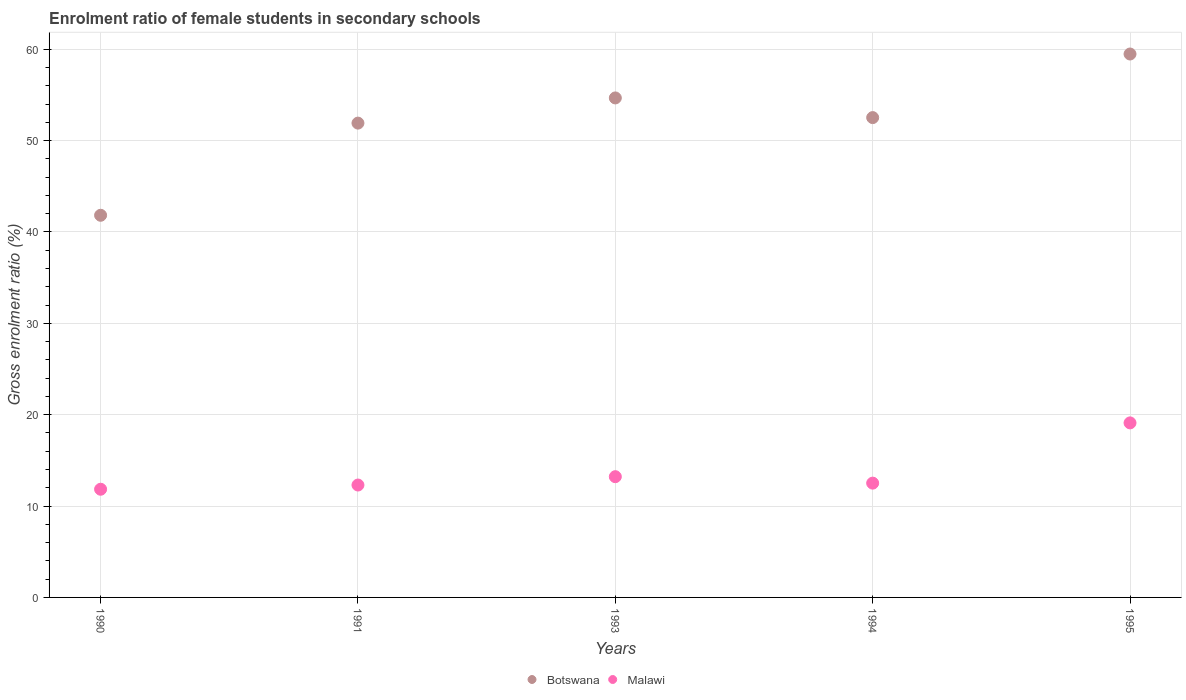Is the number of dotlines equal to the number of legend labels?
Offer a very short reply. Yes. What is the enrolment ratio of female students in secondary schools in Malawi in 1991?
Offer a very short reply. 12.3. Across all years, what is the maximum enrolment ratio of female students in secondary schools in Malawi?
Ensure brevity in your answer.  19.1. Across all years, what is the minimum enrolment ratio of female students in secondary schools in Botswana?
Give a very brief answer. 41.82. What is the total enrolment ratio of female students in secondary schools in Malawi in the graph?
Make the answer very short. 68.97. What is the difference between the enrolment ratio of female students in secondary schools in Malawi in 1990 and that in 1995?
Give a very brief answer. -7.26. What is the difference between the enrolment ratio of female students in secondary schools in Malawi in 1993 and the enrolment ratio of female students in secondary schools in Botswana in 1995?
Ensure brevity in your answer.  -46.26. What is the average enrolment ratio of female students in secondary schools in Botswana per year?
Your answer should be very brief. 52.08. In the year 1994, what is the difference between the enrolment ratio of female students in secondary schools in Botswana and enrolment ratio of female students in secondary schools in Malawi?
Provide a short and direct response. 40. In how many years, is the enrolment ratio of female students in secondary schools in Botswana greater than 48 %?
Offer a very short reply. 4. What is the ratio of the enrolment ratio of female students in secondary schools in Malawi in 1991 to that in 1995?
Your response must be concise. 0.64. Is the difference between the enrolment ratio of female students in secondary schools in Botswana in 1990 and 1993 greater than the difference between the enrolment ratio of female students in secondary schools in Malawi in 1990 and 1993?
Offer a terse response. No. What is the difference between the highest and the second highest enrolment ratio of female students in secondary schools in Botswana?
Give a very brief answer. 4.81. What is the difference between the highest and the lowest enrolment ratio of female students in secondary schools in Botswana?
Keep it short and to the point. 17.65. Is the sum of the enrolment ratio of female students in secondary schools in Malawi in 1993 and 1994 greater than the maximum enrolment ratio of female students in secondary schools in Botswana across all years?
Your answer should be compact. No. Is the enrolment ratio of female students in secondary schools in Botswana strictly greater than the enrolment ratio of female students in secondary schools in Malawi over the years?
Provide a short and direct response. Yes. How many dotlines are there?
Make the answer very short. 2. Are the values on the major ticks of Y-axis written in scientific E-notation?
Keep it short and to the point. No. Does the graph contain any zero values?
Keep it short and to the point. No. How many legend labels are there?
Keep it short and to the point. 2. How are the legend labels stacked?
Offer a very short reply. Horizontal. What is the title of the graph?
Provide a short and direct response. Enrolment ratio of female students in secondary schools. What is the label or title of the X-axis?
Your answer should be compact. Years. What is the label or title of the Y-axis?
Your answer should be very brief. Gross enrolment ratio (%). What is the Gross enrolment ratio (%) of Botswana in 1990?
Keep it short and to the point. 41.82. What is the Gross enrolment ratio (%) in Malawi in 1990?
Offer a very short reply. 11.84. What is the Gross enrolment ratio (%) in Botswana in 1991?
Make the answer very short. 51.91. What is the Gross enrolment ratio (%) of Malawi in 1991?
Your response must be concise. 12.3. What is the Gross enrolment ratio (%) in Botswana in 1993?
Make the answer very short. 54.67. What is the Gross enrolment ratio (%) in Malawi in 1993?
Provide a succinct answer. 13.21. What is the Gross enrolment ratio (%) in Botswana in 1994?
Your response must be concise. 52.51. What is the Gross enrolment ratio (%) in Malawi in 1994?
Your answer should be very brief. 12.51. What is the Gross enrolment ratio (%) of Botswana in 1995?
Keep it short and to the point. 59.47. What is the Gross enrolment ratio (%) of Malawi in 1995?
Offer a very short reply. 19.1. Across all years, what is the maximum Gross enrolment ratio (%) of Botswana?
Provide a succinct answer. 59.47. Across all years, what is the maximum Gross enrolment ratio (%) in Malawi?
Keep it short and to the point. 19.1. Across all years, what is the minimum Gross enrolment ratio (%) in Botswana?
Make the answer very short. 41.82. Across all years, what is the minimum Gross enrolment ratio (%) of Malawi?
Give a very brief answer. 11.84. What is the total Gross enrolment ratio (%) in Botswana in the graph?
Keep it short and to the point. 260.39. What is the total Gross enrolment ratio (%) in Malawi in the graph?
Your answer should be very brief. 68.97. What is the difference between the Gross enrolment ratio (%) of Botswana in 1990 and that in 1991?
Your response must be concise. -10.09. What is the difference between the Gross enrolment ratio (%) in Malawi in 1990 and that in 1991?
Your answer should be compact. -0.46. What is the difference between the Gross enrolment ratio (%) of Botswana in 1990 and that in 1993?
Offer a very short reply. -12.84. What is the difference between the Gross enrolment ratio (%) of Malawi in 1990 and that in 1993?
Your response must be concise. -1.37. What is the difference between the Gross enrolment ratio (%) of Botswana in 1990 and that in 1994?
Provide a short and direct response. -10.69. What is the difference between the Gross enrolment ratio (%) in Malawi in 1990 and that in 1994?
Make the answer very short. -0.67. What is the difference between the Gross enrolment ratio (%) in Botswana in 1990 and that in 1995?
Give a very brief answer. -17.65. What is the difference between the Gross enrolment ratio (%) in Malawi in 1990 and that in 1995?
Your answer should be compact. -7.26. What is the difference between the Gross enrolment ratio (%) in Botswana in 1991 and that in 1993?
Offer a very short reply. -2.76. What is the difference between the Gross enrolment ratio (%) in Malawi in 1991 and that in 1993?
Your response must be concise. -0.91. What is the difference between the Gross enrolment ratio (%) of Botswana in 1991 and that in 1994?
Provide a succinct answer. -0.6. What is the difference between the Gross enrolment ratio (%) of Malawi in 1991 and that in 1994?
Ensure brevity in your answer.  -0.21. What is the difference between the Gross enrolment ratio (%) of Botswana in 1991 and that in 1995?
Provide a short and direct response. -7.56. What is the difference between the Gross enrolment ratio (%) of Malawi in 1991 and that in 1995?
Give a very brief answer. -6.8. What is the difference between the Gross enrolment ratio (%) in Botswana in 1993 and that in 1994?
Ensure brevity in your answer.  2.15. What is the difference between the Gross enrolment ratio (%) in Malawi in 1993 and that in 1994?
Offer a terse response. 0.71. What is the difference between the Gross enrolment ratio (%) in Botswana in 1993 and that in 1995?
Make the answer very short. -4.81. What is the difference between the Gross enrolment ratio (%) of Malawi in 1993 and that in 1995?
Your answer should be compact. -5.89. What is the difference between the Gross enrolment ratio (%) of Botswana in 1994 and that in 1995?
Provide a succinct answer. -6.96. What is the difference between the Gross enrolment ratio (%) of Malawi in 1994 and that in 1995?
Give a very brief answer. -6.59. What is the difference between the Gross enrolment ratio (%) in Botswana in 1990 and the Gross enrolment ratio (%) in Malawi in 1991?
Offer a terse response. 29.52. What is the difference between the Gross enrolment ratio (%) in Botswana in 1990 and the Gross enrolment ratio (%) in Malawi in 1993?
Provide a succinct answer. 28.61. What is the difference between the Gross enrolment ratio (%) of Botswana in 1990 and the Gross enrolment ratio (%) of Malawi in 1994?
Provide a short and direct response. 29.32. What is the difference between the Gross enrolment ratio (%) of Botswana in 1990 and the Gross enrolment ratio (%) of Malawi in 1995?
Keep it short and to the point. 22.72. What is the difference between the Gross enrolment ratio (%) of Botswana in 1991 and the Gross enrolment ratio (%) of Malawi in 1993?
Your answer should be compact. 38.7. What is the difference between the Gross enrolment ratio (%) of Botswana in 1991 and the Gross enrolment ratio (%) of Malawi in 1994?
Your answer should be compact. 39.4. What is the difference between the Gross enrolment ratio (%) in Botswana in 1991 and the Gross enrolment ratio (%) in Malawi in 1995?
Provide a short and direct response. 32.81. What is the difference between the Gross enrolment ratio (%) in Botswana in 1993 and the Gross enrolment ratio (%) in Malawi in 1994?
Give a very brief answer. 42.16. What is the difference between the Gross enrolment ratio (%) in Botswana in 1993 and the Gross enrolment ratio (%) in Malawi in 1995?
Provide a short and direct response. 35.56. What is the difference between the Gross enrolment ratio (%) of Botswana in 1994 and the Gross enrolment ratio (%) of Malawi in 1995?
Provide a succinct answer. 33.41. What is the average Gross enrolment ratio (%) of Botswana per year?
Your answer should be very brief. 52.08. What is the average Gross enrolment ratio (%) in Malawi per year?
Your answer should be very brief. 13.79. In the year 1990, what is the difference between the Gross enrolment ratio (%) of Botswana and Gross enrolment ratio (%) of Malawi?
Offer a terse response. 29.98. In the year 1991, what is the difference between the Gross enrolment ratio (%) in Botswana and Gross enrolment ratio (%) in Malawi?
Keep it short and to the point. 39.61. In the year 1993, what is the difference between the Gross enrolment ratio (%) of Botswana and Gross enrolment ratio (%) of Malawi?
Give a very brief answer. 41.45. In the year 1994, what is the difference between the Gross enrolment ratio (%) in Botswana and Gross enrolment ratio (%) in Malawi?
Your answer should be very brief. 40. In the year 1995, what is the difference between the Gross enrolment ratio (%) in Botswana and Gross enrolment ratio (%) in Malawi?
Your response must be concise. 40.37. What is the ratio of the Gross enrolment ratio (%) of Botswana in 1990 to that in 1991?
Your response must be concise. 0.81. What is the ratio of the Gross enrolment ratio (%) in Malawi in 1990 to that in 1991?
Your answer should be very brief. 0.96. What is the ratio of the Gross enrolment ratio (%) in Botswana in 1990 to that in 1993?
Your answer should be compact. 0.77. What is the ratio of the Gross enrolment ratio (%) of Malawi in 1990 to that in 1993?
Offer a very short reply. 0.9. What is the ratio of the Gross enrolment ratio (%) of Botswana in 1990 to that in 1994?
Offer a terse response. 0.8. What is the ratio of the Gross enrolment ratio (%) of Malawi in 1990 to that in 1994?
Your answer should be compact. 0.95. What is the ratio of the Gross enrolment ratio (%) in Botswana in 1990 to that in 1995?
Your response must be concise. 0.7. What is the ratio of the Gross enrolment ratio (%) in Malawi in 1990 to that in 1995?
Provide a succinct answer. 0.62. What is the ratio of the Gross enrolment ratio (%) of Botswana in 1991 to that in 1993?
Ensure brevity in your answer.  0.95. What is the ratio of the Gross enrolment ratio (%) in Malawi in 1991 to that in 1993?
Give a very brief answer. 0.93. What is the ratio of the Gross enrolment ratio (%) of Botswana in 1991 to that in 1994?
Provide a succinct answer. 0.99. What is the ratio of the Gross enrolment ratio (%) in Malawi in 1991 to that in 1994?
Provide a succinct answer. 0.98. What is the ratio of the Gross enrolment ratio (%) of Botswana in 1991 to that in 1995?
Provide a succinct answer. 0.87. What is the ratio of the Gross enrolment ratio (%) of Malawi in 1991 to that in 1995?
Keep it short and to the point. 0.64. What is the ratio of the Gross enrolment ratio (%) of Botswana in 1993 to that in 1994?
Keep it short and to the point. 1.04. What is the ratio of the Gross enrolment ratio (%) in Malawi in 1993 to that in 1994?
Your response must be concise. 1.06. What is the ratio of the Gross enrolment ratio (%) of Botswana in 1993 to that in 1995?
Ensure brevity in your answer.  0.92. What is the ratio of the Gross enrolment ratio (%) in Malawi in 1993 to that in 1995?
Your response must be concise. 0.69. What is the ratio of the Gross enrolment ratio (%) of Botswana in 1994 to that in 1995?
Your answer should be compact. 0.88. What is the ratio of the Gross enrolment ratio (%) of Malawi in 1994 to that in 1995?
Give a very brief answer. 0.65. What is the difference between the highest and the second highest Gross enrolment ratio (%) in Botswana?
Your answer should be very brief. 4.81. What is the difference between the highest and the second highest Gross enrolment ratio (%) in Malawi?
Keep it short and to the point. 5.89. What is the difference between the highest and the lowest Gross enrolment ratio (%) in Botswana?
Give a very brief answer. 17.65. What is the difference between the highest and the lowest Gross enrolment ratio (%) of Malawi?
Keep it short and to the point. 7.26. 